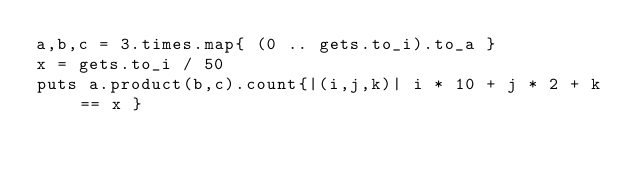Convert code to text. <code><loc_0><loc_0><loc_500><loc_500><_Ruby_>a,b,c = 3.times.map{ (0 .. gets.to_i).to_a }
x = gets.to_i / 50
puts a.product(b,c).count{|(i,j,k)| i * 10 + j * 2 + k == x }
</code> 